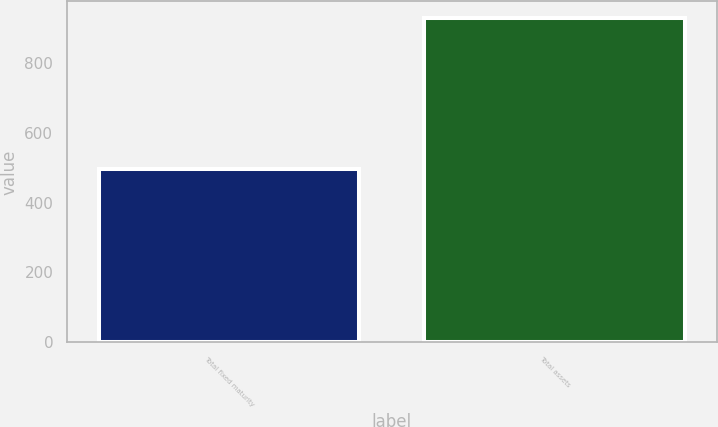Convert chart to OTSL. <chart><loc_0><loc_0><loc_500><loc_500><bar_chart><fcel>Total fixed maturity<fcel>Total assets<nl><fcel>496<fcel>930<nl></chart> 